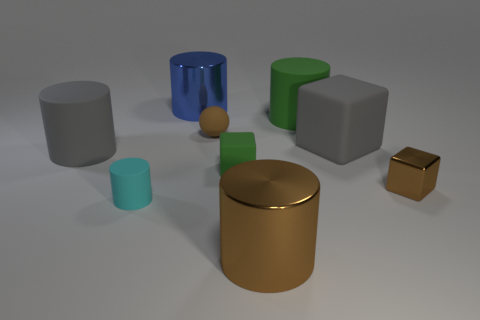Subtract all gray rubber cylinders. How many cylinders are left? 4 Subtract all brown cylinders. How many cylinders are left? 4 Subtract 3 cylinders. How many cylinders are left? 2 Add 1 red shiny cylinders. How many objects exist? 10 Subtract all brown cylinders. Subtract all blue balls. How many cylinders are left? 4 Subtract all cylinders. How many objects are left? 4 Subtract all tiny green rubber things. Subtract all cyan objects. How many objects are left? 7 Add 3 green matte cylinders. How many green matte cylinders are left? 4 Add 9 tiny balls. How many tiny balls exist? 10 Subtract 1 green blocks. How many objects are left? 8 